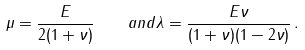<formula> <loc_0><loc_0><loc_500><loc_500>\mu = \frac { E } { 2 ( 1 + \nu ) } \quad a n d \lambda = \frac { E \nu } { ( 1 + \nu ) ( 1 - 2 \nu ) } \, .</formula> 